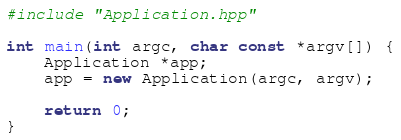<code> <loc_0><loc_0><loc_500><loc_500><_C++_>#include "Application.hpp"

int main(int argc, char const *argv[]) {
    Application *app;
    app = new Application(argc, argv);

    return 0;
}
</code> 